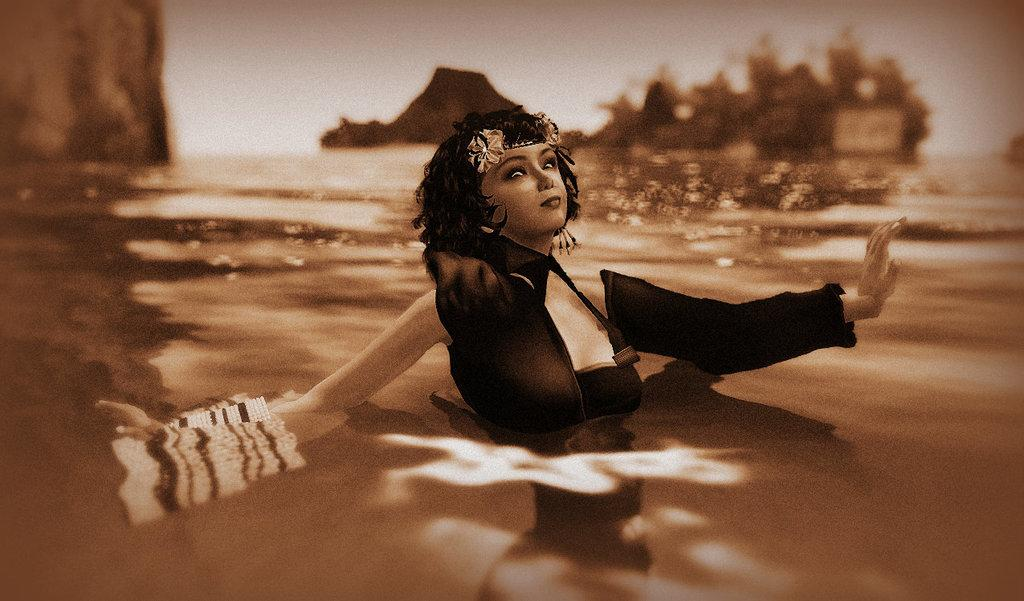What is the woman in the image doing? The woman is in the water in the image. What can be seen in the background of the image? There are trees and mountains in the background of the image. What is visible at the top of the image? The sky is visible at the top of the image. What is present at the bottom of the image? Water is present at the bottom of the image. What type of curve can be seen on the table in the image? There is no table present in the image; it features a woman in the water with trees, mountains, and sky in the background. 